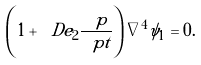<formula> <loc_0><loc_0><loc_500><loc_500>\left ( 1 + \ D e _ { 2 } \frac { \ p } { \ p t } \right ) \nabla ^ { 4 } \psi _ { 1 } = 0 .</formula> 